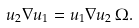<formula> <loc_0><loc_0><loc_500><loc_500>u _ { 2 } \nabla u _ { 1 } = u _ { 1 } \nabla u _ { 2 } \, \Omega .</formula> 